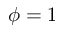Convert formula to latex. <formula><loc_0><loc_0><loc_500><loc_500>\phi = 1</formula> 